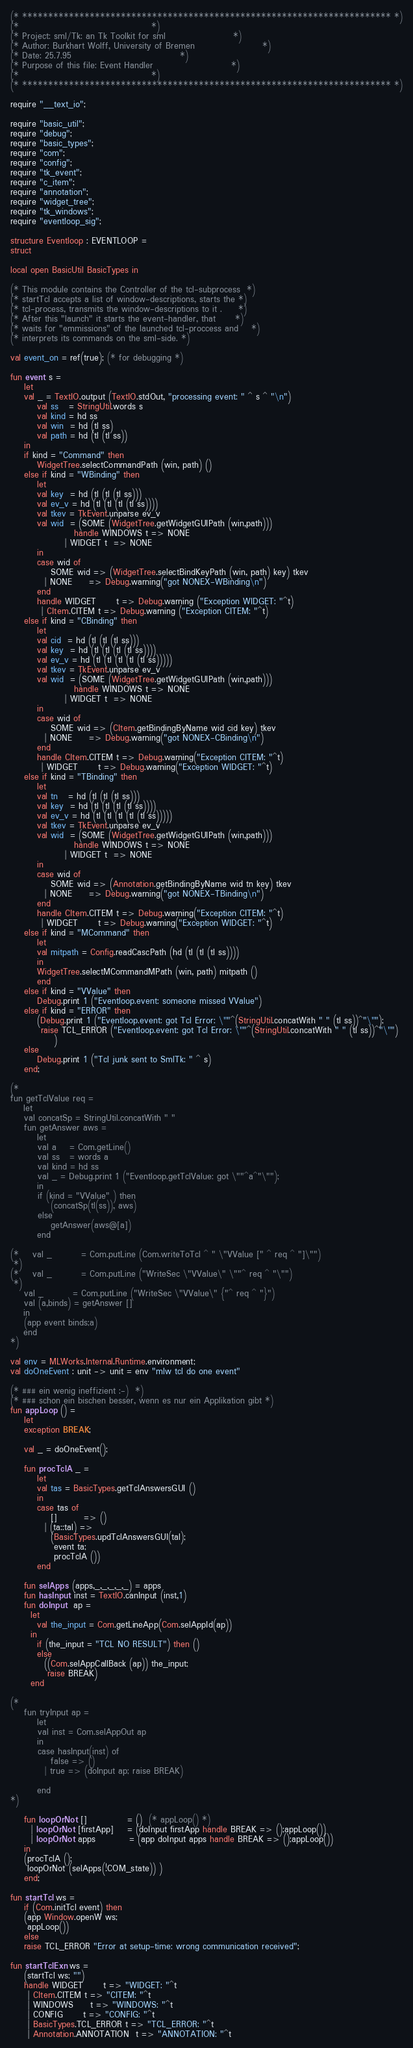Convert code to text. <code><loc_0><loc_0><loc_500><loc_500><_SML_>(* *********************************************************************** *)
(*									   *)
(* Project: sml/Tk: an Tk Toolkit for sml	 			   *)
(* Author: Burkhart Wolff, University of Bremen	 			   *)
(* Date: 25.7.95				 			   *)
(* Purpose of this file: Event Handler					   *)
(*									   *)
(* *********************************************************************** *)

require "__text_io";

require "basic_util";
require "debug";
require "basic_types";
require "com";
require "config";
require "tk_event";
require "c_item";
require "annotation";
require "widget_tree";
require "tk_windows";
require "eventloop_sig";

structure Eventloop : EVENTLOOP =
struct

local open BasicUtil BasicTypes in

(* This module contains the Controller of the tcl-subprocess  *)
(* startTcl accepts a list of window-descriptions, starts the *)
(* tcl-process, transmits the window-descriptions to it .     *)
(* After this "launch" it starts the event-handler, that      *)
(* waits for "emmissions" of the launched tcl-proccess and    *)
(* interprets its commands on the sml-side. *)

val event_on = ref(true); (* for debugging *)

fun event s =
    let 
	val _ = TextIO.output (TextIO.stdOut, "processing event: " ^ s ^ "\n")
        val ss   = StringUtil.words s
        val kind = hd ss
        val win  = hd (tl ss) 
        val path = hd (tl (tl ss))
    in  
	if kind = "Command" then 
	    WidgetTree.selectCommandPath (win, path) () 
	else if kind = "WBinding" then 
	    let 
		val key  = hd (tl (tl (tl ss)))
		val ev_v = hd (tl (tl (tl (tl ss))))
		val tkev = TkEvent.unparse ev_v
		val wid  = (SOME (WidgetTree.getWidgetGUIPath (win,path)))
		           handle WINDOWS t => NONE
				| WIDGET t  => NONE
	    in 
		case wid of 
		    SOME wid => (WidgetTree.selectBindKeyPath (win, path) key) tkev
		  | NONE     => Debug.warning("got NONEX-WBinding\n")
	    end 
	    handle WIDGET      t => Debug.warning ("Exception WIDGET: "^t)
		 | CItem.CITEM t => Debug.warning ("Exception CITEM: "^t)
	else if kind = "CBinding" then 
	    let 
		val cid  = hd (tl (tl (tl ss)))
		val key  = hd (tl (tl (tl (tl ss))))
		val ev_v = hd (tl (tl (tl (tl (tl ss)))))
		val tkev = TkEvent.unparse ev_v
		val wid  = (SOME (WidgetTree.getWidgetGUIPath (win,path)))
		           handle WINDOWS t => NONE
				| WIDGET t  => NONE
	    in 
		case wid of 
		    SOME wid => (CItem.getBindingByName wid cid key) tkev
		  | NONE     => Debug.warning("got NONEX-CBinding\n")
	    end
	    handle CItem.CITEM t => Debug.warning("Exception CITEM: "^t)
		 | WIDGET      t => Debug.warning("Exception WIDGET: "^t)
	else if kind = "TBinding" then 
	    let 
		val tn   = hd (tl (tl (tl ss)))
		val key  = hd (tl (tl (tl (tl ss))))
		val ev_v = hd (tl (tl (tl (tl (tl ss)))))
		val tkev = TkEvent.unparse ev_v
		val wid  = (SOME (WidgetTree.getWidgetGUIPath (win,path)))
		           handle WINDOWS t => NONE
				| WIDGET t  => NONE
	    in 
		case wid of 
		    SOME wid => (Annotation.getBindingByName wid tn key) tkev
		  | NONE     => Debug.warning("got NONEX-TBinding\n")
	    end
	    handle CItem.CITEM t => Debug.warning("Exception CITEM: "^t)
		 | WIDGET      t => Debug.warning("Exception WIDGET: "^t)
	else if kind = "MCommand" then  
	    let 
		val mitpath = Config.readCascPath (hd (tl (tl (tl ss))))
	    in  
		WidgetTree.selectMCommandMPath (win, path) mitpath () 
	    end
	else if kind = "VValue" then
	    Debug.print 1 ("Eventloop.event: someone missed VValue")
	else if kind = "ERROR" then
	    (Debug.print 1 ("Eventloop.event: got Tcl Error: \""^(StringUtil.concatWith " " (tl ss))^"\"");
	     raise TCL_ERROR ("Eventloop.event: got Tcl Error: \""^(StringUtil.concatWith " " (tl ss))^"\"") 
             )
	else 
	    Debug.print 1 ("Tcl junk sent to SmlTk: " ^ s)
    end;

(*
fun getTclValue req =
    let
	val concatSp = StringUtil.concatWith " "
	fun getAnswer aws =
	    let
		val a    = Com.getLine()
		val ss   = words a
		val kind = hd ss
		val _ = Debug.print 1 ("Eventloop.getTclValue: got \""^a^"\"");
	    in
		if (kind = "VValue" ) then
		    (concatSp(tl(ss)), aws)
		else
		    getAnswer(aws@[a])
	    end

(*	val _         = Com.putLine (Com.writeToTcl ^ " \"VValue [" ^ req ^ "]\"")
 *)
(*	val _         = Com.putLine ("WriteSec \"VValue\" \""^ req ^ "\"")
 *)
	val _         = Com.putLine ("WriteSec \"VValue\" {"^ req ^ "}")
	val (a,binds) = getAnswer []
    in
	(app event binds;a)
    end
*)

val env = MLWorks.Internal.Runtime.environment;
val doOneEvent : unit -> unit = env "mlw tcl do one event"

(* ### ein wenig ineffizient :-)  *)
(* ### schon ein bischen besser, wenn es nur ein Applikation gibt *)
fun appLoop () = 
    let
	exception BREAK;

	val _ = doOneEvent();

	fun procTclA _ = 
	    let
		val tas = BasicTypes.getTclAnswersGUI ()
	    in
		case tas of
		    []        => ()
		  | (ta::tal) => 
			(BasicTypes.updTclAnswersGUI(tal);
			 event ta;
			 procTclA ())
	    end

	fun selApps (apps,_,_,_,_,_) = apps
	fun hasInput inst = TextIO.canInput (inst,1)
	fun doInput  ap = 
	  let 
	    val the_input = Com.getLineApp(Com.selAppId(ap))
	  in
	    if (the_input = "TCL NO RESULT") then ()
	    else
	      ((Com.selAppCallBack (ap)) the_input;
	       raise BREAK)
	  end

(*
	fun tryInput ap = 
	    let
		val inst = Com.selAppOut ap
	    in
		case hasInput(inst) of
		    false => ()
		  | true => (doInput ap; raise BREAK)

	    end
*)

	fun loopOrNot []            = ()  (* appLoop() *)
	  | loopOrNot [firstApp]    = (doInput firstApp handle BREAK => ();appLoop()) 
	  | loopOrNot apps          = (app doInput apps handle BREAK => ();appLoop())
    in
	(procTclA ();
	 loopOrNot (selApps(!COM_state)) )
    end;

fun startTcl ws =
    if (Com.initTcl event) then 
	(app Window.openW ws; 
	 appLoop())
    else 
	raise TCL_ERROR "Error at setup-time: wrong communication received";

fun startTclExn ws = 
    (startTcl ws; "") 
    handle WIDGET      t => "WIDGET: "^t
	 | CItem.CITEM t => "CITEM: "^t
	 | WINDOWS     t => "WINDOWS: "^t
	 | CONFIG      t => "CONFIG: "^t
	 | BasicTypes.TCL_ERROR t => "TCL_ERROR: "^t
	 | Annotation.ANNOTATION  t => "ANNOTATION: "^t</code> 